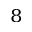<formula> <loc_0><loc_0><loc_500><loc_500>^ { 8 }</formula> 